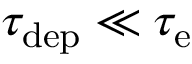<formula> <loc_0><loc_0><loc_500><loc_500>\tau _ { d e p } \ll \tau _ { e }</formula> 